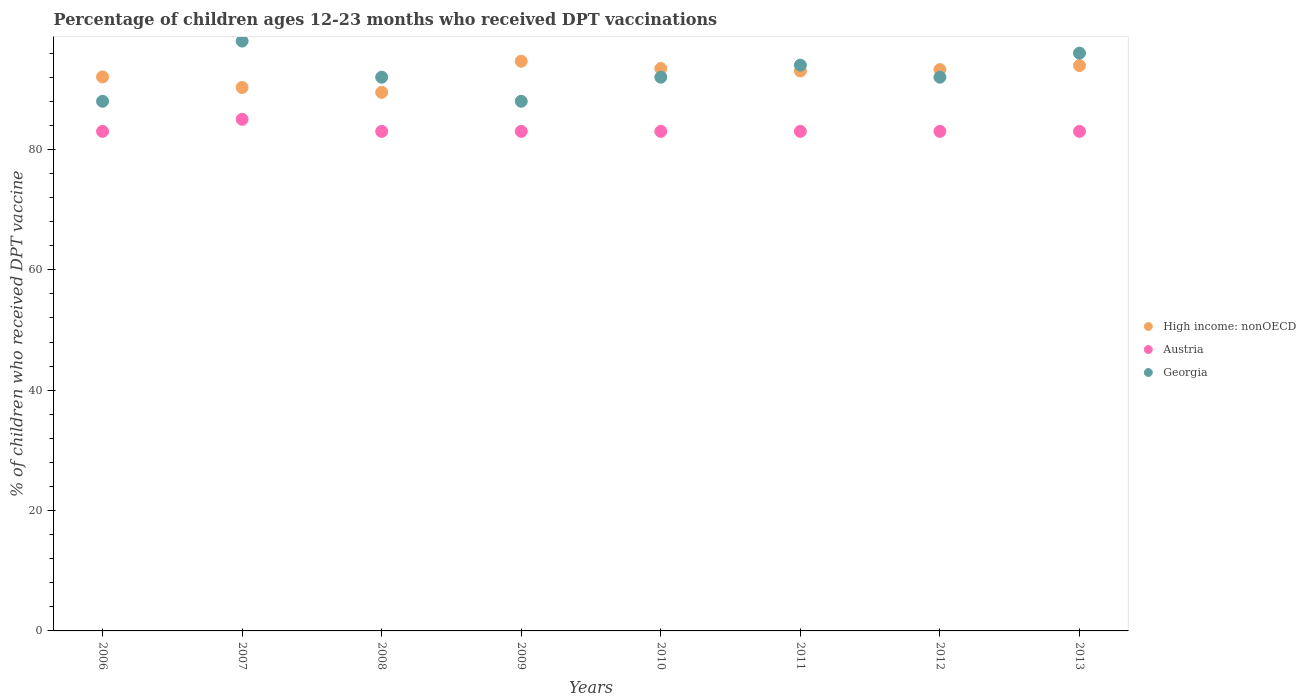How many different coloured dotlines are there?
Keep it short and to the point. 3. Is the number of dotlines equal to the number of legend labels?
Your response must be concise. Yes. What is the percentage of children who received DPT vaccination in Austria in 2009?
Provide a succinct answer. 83. Across all years, what is the maximum percentage of children who received DPT vaccination in Austria?
Keep it short and to the point. 85. Across all years, what is the minimum percentage of children who received DPT vaccination in Georgia?
Offer a terse response. 88. What is the total percentage of children who received DPT vaccination in Georgia in the graph?
Your answer should be very brief. 740. What is the average percentage of children who received DPT vaccination in High income: nonOECD per year?
Make the answer very short. 92.52. In the year 2009, what is the difference between the percentage of children who received DPT vaccination in Austria and percentage of children who received DPT vaccination in Georgia?
Your response must be concise. -5. In how many years, is the percentage of children who received DPT vaccination in Austria greater than 60 %?
Your response must be concise. 8. What is the ratio of the percentage of children who received DPT vaccination in High income: nonOECD in 2006 to that in 2011?
Make the answer very short. 0.99. Is the difference between the percentage of children who received DPT vaccination in Austria in 2012 and 2013 greater than the difference between the percentage of children who received DPT vaccination in Georgia in 2012 and 2013?
Ensure brevity in your answer.  Yes. What is the difference between the highest and the second highest percentage of children who received DPT vaccination in Austria?
Your answer should be very brief. 2. What is the difference between the highest and the lowest percentage of children who received DPT vaccination in Austria?
Provide a short and direct response. 2. Is it the case that in every year, the sum of the percentage of children who received DPT vaccination in Austria and percentage of children who received DPT vaccination in High income: nonOECD  is greater than the percentage of children who received DPT vaccination in Georgia?
Ensure brevity in your answer.  Yes. Does the percentage of children who received DPT vaccination in Austria monotonically increase over the years?
Provide a short and direct response. No. Is the percentage of children who received DPT vaccination in Austria strictly greater than the percentage of children who received DPT vaccination in Georgia over the years?
Provide a short and direct response. No. Is the percentage of children who received DPT vaccination in Austria strictly less than the percentage of children who received DPT vaccination in Georgia over the years?
Your answer should be very brief. Yes. How many dotlines are there?
Provide a short and direct response. 3. How many years are there in the graph?
Your answer should be very brief. 8. Does the graph contain any zero values?
Ensure brevity in your answer.  No. Does the graph contain grids?
Ensure brevity in your answer.  No. How many legend labels are there?
Make the answer very short. 3. How are the legend labels stacked?
Offer a very short reply. Vertical. What is the title of the graph?
Offer a very short reply. Percentage of children ages 12-23 months who received DPT vaccinations. Does "Paraguay" appear as one of the legend labels in the graph?
Your answer should be very brief. No. What is the label or title of the Y-axis?
Give a very brief answer. % of children who received DPT vaccine. What is the % of children who received DPT vaccine of High income: nonOECD in 2006?
Your response must be concise. 92.05. What is the % of children who received DPT vaccine in Georgia in 2006?
Make the answer very short. 88. What is the % of children who received DPT vaccine in High income: nonOECD in 2007?
Keep it short and to the point. 90.29. What is the % of children who received DPT vaccine of Austria in 2007?
Offer a very short reply. 85. What is the % of children who received DPT vaccine in High income: nonOECD in 2008?
Provide a succinct answer. 89.48. What is the % of children who received DPT vaccine in Georgia in 2008?
Your answer should be very brief. 92. What is the % of children who received DPT vaccine of High income: nonOECD in 2009?
Give a very brief answer. 94.66. What is the % of children who received DPT vaccine in Georgia in 2009?
Provide a short and direct response. 88. What is the % of children who received DPT vaccine of High income: nonOECD in 2010?
Your answer should be very brief. 93.44. What is the % of children who received DPT vaccine in Austria in 2010?
Your answer should be very brief. 83. What is the % of children who received DPT vaccine in Georgia in 2010?
Offer a terse response. 92. What is the % of children who received DPT vaccine of High income: nonOECD in 2011?
Provide a succinct answer. 93.03. What is the % of children who received DPT vaccine in Austria in 2011?
Give a very brief answer. 83. What is the % of children who received DPT vaccine of Georgia in 2011?
Your response must be concise. 94. What is the % of children who received DPT vaccine in High income: nonOECD in 2012?
Provide a succinct answer. 93.26. What is the % of children who received DPT vaccine in Austria in 2012?
Offer a very short reply. 83. What is the % of children who received DPT vaccine in Georgia in 2012?
Your answer should be very brief. 92. What is the % of children who received DPT vaccine of High income: nonOECD in 2013?
Provide a short and direct response. 93.94. What is the % of children who received DPT vaccine of Georgia in 2013?
Make the answer very short. 96. Across all years, what is the maximum % of children who received DPT vaccine in High income: nonOECD?
Keep it short and to the point. 94.66. Across all years, what is the maximum % of children who received DPT vaccine in Austria?
Your response must be concise. 85. Across all years, what is the maximum % of children who received DPT vaccine of Georgia?
Offer a terse response. 98. Across all years, what is the minimum % of children who received DPT vaccine in High income: nonOECD?
Provide a succinct answer. 89.48. What is the total % of children who received DPT vaccine in High income: nonOECD in the graph?
Keep it short and to the point. 740.16. What is the total % of children who received DPT vaccine in Austria in the graph?
Give a very brief answer. 666. What is the total % of children who received DPT vaccine in Georgia in the graph?
Provide a succinct answer. 740. What is the difference between the % of children who received DPT vaccine of High income: nonOECD in 2006 and that in 2007?
Ensure brevity in your answer.  1.75. What is the difference between the % of children who received DPT vaccine in Georgia in 2006 and that in 2007?
Offer a very short reply. -10. What is the difference between the % of children who received DPT vaccine of High income: nonOECD in 2006 and that in 2008?
Provide a short and direct response. 2.56. What is the difference between the % of children who received DPT vaccine in High income: nonOECD in 2006 and that in 2009?
Make the answer very short. -2.61. What is the difference between the % of children who received DPT vaccine of Georgia in 2006 and that in 2009?
Give a very brief answer. 0. What is the difference between the % of children who received DPT vaccine in High income: nonOECD in 2006 and that in 2010?
Offer a terse response. -1.39. What is the difference between the % of children who received DPT vaccine in Austria in 2006 and that in 2010?
Ensure brevity in your answer.  0. What is the difference between the % of children who received DPT vaccine of Georgia in 2006 and that in 2010?
Make the answer very short. -4. What is the difference between the % of children who received DPT vaccine of High income: nonOECD in 2006 and that in 2011?
Your response must be concise. -0.99. What is the difference between the % of children who received DPT vaccine in Georgia in 2006 and that in 2011?
Provide a succinct answer. -6. What is the difference between the % of children who received DPT vaccine in High income: nonOECD in 2006 and that in 2012?
Keep it short and to the point. -1.22. What is the difference between the % of children who received DPT vaccine in Georgia in 2006 and that in 2012?
Give a very brief answer. -4. What is the difference between the % of children who received DPT vaccine in High income: nonOECD in 2006 and that in 2013?
Offer a very short reply. -1.89. What is the difference between the % of children who received DPT vaccine in High income: nonOECD in 2007 and that in 2008?
Offer a terse response. 0.81. What is the difference between the % of children who received DPT vaccine in Austria in 2007 and that in 2008?
Keep it short and to the point. 2. What is the difference between the % of children who received DPT vaccine in Georgia in 2007 and that in 2008?
Give a very brief answer. 6. What is the difference between the % of children who received DPT vaccine in High income: nonOECD in 2007 and that in 2009?
Offer a terse response. -4.36. What is the difference between the % of children who received DPT vaccine in Austria in 2007 and that in 2009?
Your answer should be compact. 2. What is the difference between the % of children who received DPT vaccine of High income: nonOECD in 2007 and that in 2010?
Provide a succinct answer. -3.14. What is the difference between the % of children who received DPT vaccine in Austria in 2007 and that in 2010?
Keep it short and to the point. 2. What is the difference between the % of children who received DPT vaccine of Georgia in 2007 and that in 2010?
Provide a succinct answer. 6. What is the difference between the % of children who received DPT vaccine of High income: nonOECD in 2007 and that in 2011?
Your answer should be compact. -2.74. What is the difference between the % of children who received DPT vaccine of Austria in 2007 and that in 2011?
Provide a short and direct response. 2. What is the difference between the % of children who received DPT vaccine in High income: nonOECD in 2007 and that in 2012?
Give a very brief answer. -2.97. What is the difference between the % of children who received DPT vaccine of Georgia in 2007 and that in 2012?
Provide a succinct answer. 6. What is the difference between the % of children who received DPT vaccine in High income: nonOECD in 2007 and that in 2013?
Ensure brevity in your answer.  -3.64. What is the difference between the % of children who received DPT vaccine in Austria in 2007 and that in 2013?
Provide a short and direct response. 2. What is the difference between the % of children who received DPT vaccine in High income: nonOECD in 2008 and that in 2009?
Your answer should be compact. -5.17. What is the difference between the % of children who received DPT vaccine of High income: nonOECD in 2008 and that in 2010?
Offer a very short reply. -3.95. What is the difference between the % of children who received DPT vaccine of High income: nonOECD in 2008 and that in 2011?
Offer a terse response. -3.55. What is the difference between the % of children who received DPT vaccine in Georgia in 2008 and that in 2011?
Provide a succinct answer. -2. What is the difference between the % of children who received DPT vaccine of High income: nonOECD in 2008 and that in 2012?
Provide a short and direct response. -3.78. What is the difference between the % of children who received DPT vaccine of Georgia in 2008 and that in 2012?
Your answer should be compact. 0. What is the difference between the % of children who received DPT vaccine of High income: nonOECD in 2008 and that in 2013?
Provide a succinct answer. -4.45. What is the difference between the % of children who received DPT vaccine in High income: nonOECD in 2009 and that in 2010?
Your answer should be very brief. 1.22. What is the difference between the % of children who received DPT vaccine in High income: nonOECD in 2009 and that in 2011?
Your answer should be very brief. 1.63. What is the difference between the % of children who received DPT vaccine in Austria in 2009 and that in 2011?
Offer a terse response. 0. What is the difference between the % of children who received DPT vaccine in Georgia in 2009 and that in 2011?
Make the answer very short. -6. What is the difference between the % of children who received DPT vaccine in High income: nonOECD in 2009 and that in 2012?
Offer a very short reply. 1.39. What is the difference between the % of children who received DPT vaccine in Austria in 2009 and that in 2012?
Your response must be concise. 0. What is the difference between the % of children who received DPT vaccine of High income: nonOECD in 2009 and that in 2013?
Ensure brevity in your answer.  0.72. What is the difference between the % of children who received DPT vaccine of High income: nonOECD in 2010 and that in 2011?
Keep it short and to the point. 0.4. What is the difference between the % of children who received DPT vaccine in Georgia in 2010 and that in 2011?
Offer a very short reply. -2. What is the difference between the % of children who received DPT vaccine in High income: nonOECD in 2010 and that in 2012?
Provide a succinct answer. 0.17. What is the difference between the % of children who received DPT vaccine of Austria in 2010 and that in 2012?
Provide a succinct answer. 0. What is the difference between the % of children who received DPT vaccine in High income: nonOECD in 2010 and that in 2013?
Provide a succinct answer. -0.5. What is the difference between the % of children who received DPT vaccine of Georgia in 2010 and that in 2013?
Keep it short and to the point. -4. What is the difference between the % of children who received DPT vaccine of High income: nonOECD in 2011 and that in 2012?
Offer a very short reply. -0.23. What is the difference between the % of children who received DPT vaccine in Austria in 2011 and that in 2012?
Keep it short and to the point. 0. What is the difference between the % of children who received DPT vaccine of Georgia in 2011 and that in 2012?
Provide a short and direct response. 2. What is the difference between the % of children who received DPT vaccine in High income: nonOECD in 2011 and that in 2013?
Keep it short and to the point. -0.91. What is the difference between the % of children who received DPT vaccine in Austria in 2011 and that in 2013?
Your answer should be very brief. 0. What is the difference between the % of children who received DPT vaccine of Georgia in 2011 and that in 2013?
Offer a very short reply. -2. What is the difference between the % of children who received DPT vaccine of High income: nonOECD in 2012 and that in 2013?
Make the answer very short. -0.67. What is the difference between the % of children who received DPT vaccine in Austria in 2012 and that in 2013?
Give a very brief answer. 0. What is the difference between the % of children who received DPT vaccine in High income: nonOECD in 2006 and the % of children who received DPT vaccine in Austria in 2007?
Keep it short and to the point. 7.05. What is the difference between the % of children who received DPT vaccine of High income: nonOECD in 2006 and the % of children who received DPT vaccine of Georgia in 2007?
Provide a short and direct response. -5.95. What is the difference between the % of children who received DPT vaccine in High income: nonOECD in 2006 and the % of children who received DPT vaccine in Austria in 2008?
Offer a very short reply. 9.05. What is the difference between the % of children who received DPT vaccine of High income: nonOECD in 2006 and the % of children who received DPT vaccine of Georgia in 2008?
Your response must be concise. 0.05. What is the difference between the % of children who received DPT vaccine in High income: nonOECD in 2006 and the % of children who received DPT vaccine in Austria in 2009?
Provide a short and direct response. 9.05. What is the difference between the % of children who received DPT vaccine in High income: nonOECD in 2006 and the % of children who received DPT vaccine in Georgia in 2009?
Provide a succinct answer. 4.05. What is the difference between the % of children who received DPT vaccine of Austria in 2006 and the % of children who received DPT vaccine of Georgia in 2009?
Your response must be concise. -5. What is the difference between the % of children who received DPT vaccine in High income: nonOECD in 2006 and the % of children who received DPT vaccine in Austria in 2010?
Your response must be concise. 9.05. What is the difference between the % of children who received DPT vaccine of High income: nonOECD in 2006 and the % of children who received DPT vaccine of Georgia in 2010?
Your response must be concise. 0.05. What is the difference between the % of children who received DPT vaccine of High income: nonOECD in 2006 and the % of children who received DPT vaccine of Austria in 2011?
Your answer should be very brief. 9.05. What is the difference between the % of children who received DPT vaccine of High income: nonOECD in 2006 and the % of children who received DPT vaccine of Georgia in 2011?
Your answer should be compact. -1.95. What is the difference between the % of children who received DPT vaccine in Austria in 2006 and the % of children who received DPT vaccine in Georgia in 2011?
Your response must be concise. -11. What is the difference between the % of children who received DPT vaccine of High income: nonOECD in 2006 and the % of children who received DPT vaccine of Austria in 2012?
Keep it short and to the point. 9.05. What is the difference between the % of children who received DPT vaccine of High income: nonOECD in 2006 and the % of children who received DPT vaccine of Georgia in 2012?
Offer a terse response. 0.05. What is the difference between the % of children who received DPT vaccine of Austria in 2006 and the % of children who received DPT vaccine of Georgia in 2012?
Make the answer very short. -9. What is the difference between the % of children who received DPT vaccine in High income: nonOECD in 2006 and the % of children who received DPT vaccine in Austria in 2013?
Make the answer very short. 9.05. What is the difference between the % of children who received DPT vaccine in High income: nonOECD in 2006 and the % of children who received DPT vaccine in Georgia in 2013?
Offer a terse response. -3.95. What is the difference between the % of children who received DPT vaccine in High income: nonOECD in 2007 and the % of children who received DPT vaccine in Austria in 2008?
Give a very brief answer. 7.29. What is the difference between the % of children who received DPT vaccine of High income: nonOECD in 2007 and the % of children who received DPT vaccine of Georgia in 2008?
Make the answer very short. -1.71. What is the difference between the % of children who received DPT vaccine of Austria in 2007 and the % of children who received DPT vaccine of Georgia in 2008?
Your answer should be very brief. -7. What is the difference between the % of children who received DPT vaccine of High income: nonOECD in 2007 and the % of children who received DPT vaccine of Austria in 2009?
Provide a succinct answer. 7.29. What is the difference between the % of children who received DPT vaccine of High income: nonOECD in 2007 and the % of children who received DPT vaccine of Georgia in 2009?
Your answer should be very brief. 2.29. What is the difference between the % of children who received DPT vaccine of Austria in 2007 and the % of children who received DPT vaccine of Georgia in 2009?
Your answer should be very brief. -3. What is the difference between the % of children who received DPT vaccine of High income: nonOECD in 2007 and the % of children who received DPT vaccine of Austria in 2010?
Your answer should be very brief. 7.29. What is the difference between the % of children who received DPT vaccine of High income: nonOECD in 2007 and the % of children who received DPT vaccine of Georgia in 2010?
Offer a terse response. -1.71. What is the difference between the % of children who received DPT vaccine of Austria in 2007 and the % of children who received DPT vaccine of Georgia in 2010?
Your response must be concise. -7. What is the difference between the % of children who received DPT vaccine of High income: nonOECD in 2007 and the % of children who received DPT vaccine of Austria in 2011?
Your answer should be compact. 7.29. What is the difference between the % of children who received DPT vaccine in High income: nonOECD in 2007 and the % of children who received DPT vaccine in Georgia in 2011?
Keep it short and to the point. -3.71. What is the difference between the % of children who received DPT vaccine of Austria in 2007 and the % of children who received DPT vaccine of Georgia in 2011?
Keep it short and to the point. -9. What is the difference between the % of children who received DPT vaccine of High income: nonOECD in 2007 and the % of children who received DPT vaccine of Austria in 2012?
Offer a very short reply. 7.29. What is the difference between the % of children who received DPT vaccine in High income: nonOECD in 2007 and the % of children who received DPT vaccine in Georgia in 2012?
Keep it short and to the point. -1.71. What is the difference between the % of children who received DPT vaccine of Austria in 2007 and the % of children who received DPT vaccine of Georgia in 2012?
Your answer should be very brief. -7. What is the difference between the % of children who received DPT vaccine of High income: nonOECD in 2007 and the % of children who received DPT vaccine of Austria in 2013?
Give a very brief answer. 7.29. What is the difference between the % of children who received DPT vaccine in High income: nonOECD in 2007 and the % of children who received DPT vaccine in Georgia in 2013?
Your answer should be compact. -5.71. What is the difference between the % of children who received DPT vaccine in High income: nonOECD in 2008 and the % of children who received DPT vaccine in Austria in 2009?
Provide a short and direct response. 6.48. What is the difference between the % of children who received DPT vaccine in High income: nonOECD in 2008 and the % of children who received DPT vaccine in Georgia in 2009?
Your response must be concise. 1.48. What is the difference between the % of children who received DPT vaccine in Austria in 2008 and the % of children who received DPT vaccine in Georgia in 2009?
Keep it short and to the point. -5. What is the difference between the % of children who received DPT vaccine in High income: nonOECD in 2008 and the % of children who received DPT vaccine in Austria in 2010?
Keep it short and to the point. 6.48. What is the difference between the % of children who received DPT vaccine of High income: nonOECD in 2008 and the % of children who received DPT vaccine of Georgia in 2010?
Your answer should be compact. -2.52. What is the difference between the % of children who received DPT vaccine of Austria in 2008 and the % of children who received DPT vaccine of Georgia in 2010?
Provide a short and direct response. -9. What is the difference between the % of children who received DPT vaccine in High income: nonOECD in 2008 and the % of children who received DPT vaccine in Austria in 2011?
Keep it short and to the point. 6.48. What is the difference between the % of children who received DPT vaccine in High income: nonOECD in 2008 and the % of children who received DPT vaccine in Georgia in 2011?
Offer a terse response. -4.52. What is the difference between the % of children who received DPT vaccine of High income: nonOECD in 2008 and the % of children who received DPT vaccine of Austria in 2012?
Your response must be concise. 6.48. What is the difference between the % of children who received DPT vaccine in High income: nonOECD in 2008 and the % of children who received DPT vaccine in Georgia in 2012?
Your response must be concise. -2.52. What is the difference between the % of children who received DPT vaccine in High income: nonOECD in 2008 and the % of children who received DPT vaccine in Austria in 2013?
Your response must be concise. 6.48. What is the difference between the % of children who received DPT vaccine of High income: nonOECD in 2008 and the % of children who received DPT vaccine of Georgia in 2013?
Provide a short and direct response. -6.52. What is the difference between the % of children who received DPT vaccine of High income: nonOECD in 2009 and the % of children who received DPT vaccine of Austria in 2010?
Offer a terse response. 11.66. What is the difference between the % of children who received DPT vaccine of High income: nonOECD in 2009 and the % of children who received DPT vaccine of Georgia in 2010?
Your answer should be very brief. 2.66. What is the difference between the % of children who received DPT vaccine in Austria in 2009 and the % of children who received DPT vaccine in Georgia in 2010?
Your response must be concise. -9. What is the difference between the % of children who received DPT vaccine of High income: nonOECD in 2009 and the % of children who received DPT vaccine of Austria in 2011?
Your answer should be very brief. 11.66. What is the difference between the % of children who received DPT vaccine of High income: nonOECD in 2009 and the % of children who received DPT vaccine of Georgia in 2011?
Provide a short and direct response. 0.66. What is the difference between the % of children who received DPT vaccine of Austria in 2009 and the % of children who received DPT vaccine of Georgia in 2011?
Keep it short and to the point. -11. What is the difference between the % of children who received DPT vaccine of High income: nonOECD in 2009 and the % of children who received DPT vaccine of Austria in 2012?
Make the answer very short. 11.66. What is the difference between the % of children who received DPT vaccine of High income: nonOECD in 2009 and the % of children who received DPT vaccine of Georgia in 2012?
Ensure brevity in your answer.  2.66. What is the difference between the % of children who received DPT vaccine of Austria in 2009 and the % of children who received DPT vaccine of Georgia in 2012?
Offer a very short reply. -9. What is the difference between the % of children who received DPT vaccine in High income: nonOECD in 2009 and the % of children who received DPT vaccine in Austria in 2013?
Offer a terse response. 11.66. What is the difference between the % of children who received DPT vaccine in High income: nonOECD in 2009 and the % of children who received DPT vaccine in Georgia in 2013?
Provide a succinct answer. -1.34. What is the difference between the % of children who received DPT vaccine of High income: nonOECD in 2010 and the % of children who received DPT vaccine of Austria in 2011?
Give a very brief answer. 10.44. What is the difference between the % of children who received DPT vaccine in High income: nonOECD in 2010 and the % of children who received DPT vaccine in Georgia in 2011?
Give a very brief answer. -0.56. What is the difference between the % of children who received DPT vaccine in Austria in 2010 and the % of children who received DPT vaccine in Georgia in 2011?
Your answer should be very brief. -11. What is the difference between the % of children who received DPT vaccine in High income: nonOECD in 2010 and the % of children who received DPT vaccine in Austria in 2012?
Provide a short and direct response. 10.44. What is the difference between the % of children who received DPT vaccine in High income: nonOECD in 2010 and the % of children who received DPT vaccine in Georgia in 2012?
Your answer should be compact. 1.44. What is the difference between the % of children who received DPT vaccine of Austria in 2010 and the % of children who received DPT vaccine of Georgia in 2012?
Provide a short and direct response. -9. What is the difference between the % of children who received DPT vaccine in High income: nonOECD in 2010 and the % of children who received DPT vaccine in Austria in 2013?
Offer a very short reply. 10.44. What is the difference between the % of children who received DPT vaccine of High income: nonOECD in 2010 and the % of children who received DPT vaccine of Georgia in 2013?
Give a very brief answer. -2.56. What is the difference between the % of children who received DPT vaccine in Austria in 2010 and the % of children who received DPT vaccine in Georgia in 2013?
Offer a terse response. -13. What is the difference between the % of children who received DPT vaccine of High income: nonOECD in 2011 and the % of children who received DPT vaccine of Austria in 2012?
Your answer should be compact. 10.03. What is the difference between the % of children who received DPT vaccine of High income: nonOECD in 2011 and the % of children who received DPT vaccine of Georgia in 2012?
Provide a short and direct response. 1.03. What is the difference between the % of children who received DPT vaccine in High income: nonOECD in 2011 and the % of children who received DPT vaccine in Austria in 2013?
Make the answer very short. 10.03. What is the difference between the % of children who received DPT vaccine of High income: nonOECD in 2011 and the % of children who received DPT vaccine of Georgia in 2013?
Give a very brief answer. -2.97. What is the difference between the % of children who received DPT vaccine of High income: nonOECD in 2012 and the % of children who received DPT vaccine of Austria in 2013?
Your response must be concise. 10.26. What is the difference between the % of children who received DPT vaccine in High income: nonOECD in 2012 and the % of children who received DPT vaccine in Georgia in 2013?
Provide a short and direct response. -2.74. What is the difference between the % of children who received DPT vaccine of Austria in 2012 and the % of children who received DPT vaccine of Georgia in 2013?
Offer a terse response. -13. What is the average % of children who received DPT vaccine of High income: nonOECD per year?
Give a very brief answer. 92.52. What is the average % of children who received DPT vaccine in Austria per year?
Offer a very short reply. 83.25. What is the average % of children who received DPT vaccine in Georgia per year?
Offer a terse response. 92.5. In the year 2006, what is the difference between the % of children who received DPT vaccine in High income: nonOECD and % of children who received DPT vaccine in Austria?
Provide a succinct answer. 9.05. In the year 2006, what is the difference between the % of children who received DPT vaccine in High income: nonOECD and % of children who received DPT vaccine in Georgia?
Provide a short and direct response. 4.05. In the year 2007, what is the difference between the % of children who received DPT vaccine of High income: nonOECD and % of children who received DPT vaccine of Austria?
Make the answer very short. 5.29. In the year 2007, what is the difference between the % of children who received DPT vaccine of High income: nonOECD and % of children who received DPT vaccine of Georgia?
Your answer should be compact. -7.71. In the year 2008, what is the difference between the % of children who received DPT vaccine in High income: nonOECD and % of children who received DPT vaccine in Austria?
Your answer should be compact. 6.48. In the year 2008, what is the difference between the % of children who received DPT vaccine in High income: nonOECD and % of children who received DPT vaccine in Georgia?
Provide a short and direct response. -2.52. In the year 2009, what is the difference between the % of children who received DPT vaccine of High income: nonOECD and % of children who received DPT vaccine of Austria?
Give a very brief answer. 11.66. In the year 2009, what is the difference between the % of children who received DPT vaccine of High income: nonOECD and % of children who received DPT vaccine of Georgia?
Provide a short and direct response. 6.66. In the year 2010, what is the difference between the % of children who received DPT vaccine of High income: nonOECD and % of children who received DPT vaccine of Austria?
Give a very brief answer. 10.44. In the year 2010, what is the difference between the % of children who received DPT vaccine of High income: nonOECD and % of children who received DPT vaccine of Georgia?
Give a very brief answer. 1.44. In the year 2010, what is the difference between the % of children who received DPT vaccine of Austria and % of children who received DPT vaccine of Georgia?
Your answer should be compact. -9. In the year 2011, what is the difference between the % of children who received DPT vaccine in High income: nonOECD and % of children who received DPT vaccine in Austria?
Ensure brevity in your answer.  10.03. In the year 2011, what is the difference between the % of children who received DPT vaccine in High income: nonOECD and % of children who received DPT vaccine in Georgia?
Keep it short and to the point. -0.97. In the year 2012, what is the difference between the % of children who received DPT vaccine in High income: nonOECD and % of children who received DPT vaccine in Austria?
Offer a terse response. 10.26. In the year 2012, what is the difference between the % of children who received DPT vaccine in High income: nonOECD and % of children who received DPT vaccine in Georgia?
Your answer should be very brief. 1.26. In the year 2012, what is the difference between the % of children who received DPT vaccine in Austria and % of children who received DPT vaccine in Georgia?
Provide a succinct answer. -9. In the year 2013, what is the difference between the % of children who received DPT vaccine of High income: nonOECD and % of children who received DPT vaccine of Austria?
Your answer should be very brief. 10.94. In the year 2013, what is the difference between the % of children who received DPT vaccine of High income: nonOECD and % of children who received DPT vaccine of Georgia?
Your response must be concise. -2.06. In the year 2013, what is the difference between the % of children who received DPT vaccine of Austria and % of children who received DPT vaccine of Georgia?
Provide a short and direct response. -13. What is the ratio of the % of children who received DPT vaccine of High income: nonOECD in 2006 to that in 2007?
Provide a succinct answer. 1.02. What is the ratio of the % of children who received DPT vaccine of Austria in 2006 to that in 2007?
Provide a short and direct response. 0.98. What is the ratio of the % of children who received DPT vaccine in Georgia in 2006 to that in 2007?
Your response must be concise. 0.9. What is the ratio of the % of children who received DPT vaccine of High income: nonOECD in 2006 to that in 2008?
Make the answer very short. 1.03. What is the ratio of the % of children who received DPT vaccine of Austria in 2006 to that in 2008?
Offer a terse response. 1. What is the ratio of the % of children who received DPT vaccine in Georgia in 2006 to that in 2008?
Provide a short and direct response. 0.96. What is the ratio of the % of children who received DPT vaccine in High income: nonOECD in 2006 to that in 2009?
Your answer should be compact. 0.97. What is the ratio of the % of children who received DPT vaccine in Georgia in 2006 to that in 2009?
Your answer should be compact. 1. What is the ratio of the % of children who received DPT vaccine of High income: nonOECD in 2006 to that in 2010?
Offer a very short reply. 0.99. What is the ratio of the % of children who received DPT vaccine in Austria in 2006 to that in 2010?
Make the answer very short. 1. What is the ratio of the % of children who received DPT vaccine of Georgia in 2006 to that in 2010?
Provide a short and direct response. 0.96. What is the ratio of the % of children who received DPT vaccine in Austria in 2006 to that in 2011?
Offer a very short reply. 1. What is the ratio of the % of children who received DPT vaccine of Georgia in 2006 to that in 2011?
Keep it short and to the point. 0.94. What is the ratio of the % of children who received DPT vaccine in High income: nonOECD in 2006 to that in 2012?
Your response must be concise. 0.99. What is the ratio of the % of children who received DPT vaccine in Austria in 2006 to that in 2012?
Your answer should be very brief. 1. What is the ratio of the % of children who received DPT vaccine in Georgia in 2006 to that in 2012?
Offer a terse response. 0.96. What is the ratio of the % of children who received DPT vaccine of High income: nonOECD in 2006 to that in 2013?
Give a very brief answer. 0.98. What is the ratio of the % of children who received DPT vaccine of Austria in 2007 to that in 2008?
Keep it short and to the point. 1.02. What is the ratio of the % of children who received DPT vaccine in Georgia in 2007 to that in 2008?
Give a very brief answer. 1.07. What is the ratio of the % of children who received DPT vaccine of High income: nonOECD in 2007 to that in 2009?
Give a very brief answer. 0.95. What is the ratio of the % of children who received DPT vaccine in Austria in 2007 to that in 2009?
Provide a succinct answer. 1.02. What is the ratio of the % of children who received DPT vaccine of Georgia in 2007 to that in 2009?
Offer a very short reply. 1.11. What is the ratio of the % of children who received DPT vaccine of High income: nonOECD in 2007 to that in 2010?
Keep it short and to the point. 0.97. What is the ratio of the % of children who received DPT vaccine of Austria in 2007 to that in 2010?
Give a very brief answer. 1.02. What is the ratio of the % of children who received DPT vaccine in Georgia in 2007 to that in 2010?
Provide a succinct answer. 1.07. What is the ratio of the % of children who received DPT vaccine of High income: nonOECD in 2007 to that in 2011?
Give a very brief answer. 0.97. What is the ratio of the % of children who received DPT vaccine in Austria in 2007 to that in 2011?
Your answer should be very brief. 1.02. What is the ratio of the % of children who received DPT vaccine in Georgia in 2007 to that in 2011?
Offer a very short reply. 1.04. What is the ratio of the % of children who received DPT vaccine in High income: nonOECD in 2007 to that in 2012?
Make the answer very short. 0.97. What is the ratio of the % of children who received DPT vaccine of Austria in 2007 to that in 2012?
Your answer should be compact. 1.02. What is the ratio of the % of children who received DPT vaccine in Georgia in 2007 to that in 2012?
Ensure brevity in your answer.  1.07. What is the ratio of the % of children who received DPT vaccine in High income: nonOECD in 2007 to that in 2013?
Your answer should be compact. 0.96. What is the ratio of the % of children who received DPT vaccine of Austria in 2007 to that in 2013?
Ensure brevity in your answer.  1.02. What is the ratio of the % of children who received DPT vaccine in Georgia in 2007 to that in 2013?
Ensure brevity in your answer.  1.02. What is the ratio of the % of children who received DPT vaccine in High income: nonOECD in 2008 to that in 2009?
Offer a terse response. 0.95. What is the ratio of the % of children who received DPT vaccine in Georgia in 2008 to that in 2009?
Your response must be concise. 1.05. What is the ratio of the % of children who received DPT vaccine of High income: nonOECD in 2008 to that in 2010?
Your response must be concise. 0.96. What is the ratio of the % of children who received DPT vaccine in Austria in 2008 to that in 2010?
Make the answer very short. 1. What is the ratio of the % of children who received DPT vaccine of Georgia in 2008 to that in 2010?
Ensure brevity in your answer.  1. What is the ratio of the % of children who received DPT vaccine in High income: nonOECD in 2008 to that in 2011?
Provide a short and direct response. 0.96. What is the ratio of the % of children who received DPT vaccine of Austria in 2008 to that in 2011?
Your response must be concise. 1. What is the ratio of the % of children who received DPT vaccine of Georgia in 2008 to that in 2011?
Make the answer very short. 0.98. What is the ratio of the % of children who received DPT vaccine in High income: nonOECD in 2008 to that in 2012?
Ensure brevity in your answer.  0.96. What is the ratio of the % of children who received DPT vaccine of Georgia in 2008 to that in 2012?
Keep it short and to the point. 1. What is the ratio of the % of children who received DPT vaccine in High income: nonOECD in 2008 to that in 2013?
Give a very brief answer. 0.95. What is the ratio of the % of children who received DPT vaccine in High income: nonOECD in 2009 to that in 2010?
Make the answer very short. 1.01. What is the ratio of the % of children who received DPT vaccine in Austria in 2009 to that in 2010?
Your answer should be compact. 1. What is the ratio of the % of children who received DPT vaccine in Georgia in 2009 to that in 2010?
Keep it short and to the point. 0.96. What is the ratio of the % of children who received DPT vaccine in High income: nonOECD in 2009 to that in 2011?
Offer a very short reply. 1.02. What is the ratio of the % of children who received DPT vaccine in Austria in 2009 to that in 2011?
Give a very brief answer. 1. What is the ratio of the % of children who received DPT vaccine of Georgia in 2009 to that in 2011?
Offer a very short reply. 0.94. What is the ratio of the % of children who received DPT vaccine of High income: nonOECD in 2009 to that in 2012?
Provide a short and direct response. 1.01. What is the ratio of the % of children who received DPT vaccine in Georgia in 2009 to that in 2012?
Keep it short and to the point. 0.96. What is the ratio of the % of children who received DPT vaccine in High income: nonOECD in 2009 to that in 2013?
Keep it short and to the point. 1.01. What is the ratio of the % of children who received DPT vaccine of Georgia in 2009 to that in 2013?
Make the answer very short. 0.92. What is the ratio of the % of children who received DPT vaccine in Austria in 2010 to that in 2011?
Keep it short and to the point. 1. What is the ratio of the % of children who received DPT vaccine of Georgia in 2010 to that in 2011?
Your answer should be compact. 0.98. What is the ratio of the % of children who received DPT vaccine in Austria in 2010 to that in 2012?
Ensure brevity in your answer.  1. What is the ratio of the % of children who received DPT vaccine of Georgia in 2010 to that in 2012?
Offer a terse response. 1. What is the ratio of the % of children who received DPT vaccine of Georgia in 2010 to that in 2013?
Your response must be concise. 0.96. What is the ratio of the % of children who received DPT vaccine in Austria in 2011 to that in 2012?
Offer a terse response. 1. What is the ratio of the % of children who received DPT vaccine of Georgia in 2011 to that in 2012?
Offer a terse response. 1.02. What is the ratio of the % of children who received DPT vaccine in Georgia in 2011 to that in 2013?
Offer a terse response. 0.98. What is the ratio of the % of children who received DPT vaccine of Austria in 2012 to that in 2013?
Give a very brief answer. 1. What is the difference between the highest and the second highest % of children who received DPT vaccine of High income: nonOECD?
Your response must be concise. 0.72. What is the difference between the highest and the lowest % of children who received DPT vaccine in High income: nonOECD?
Ensure brevity in your answer.  5.17. What is the difference between the highest and the lowest % of children who received DPT vaccine of Austria?
Offer a terse response. 2. 